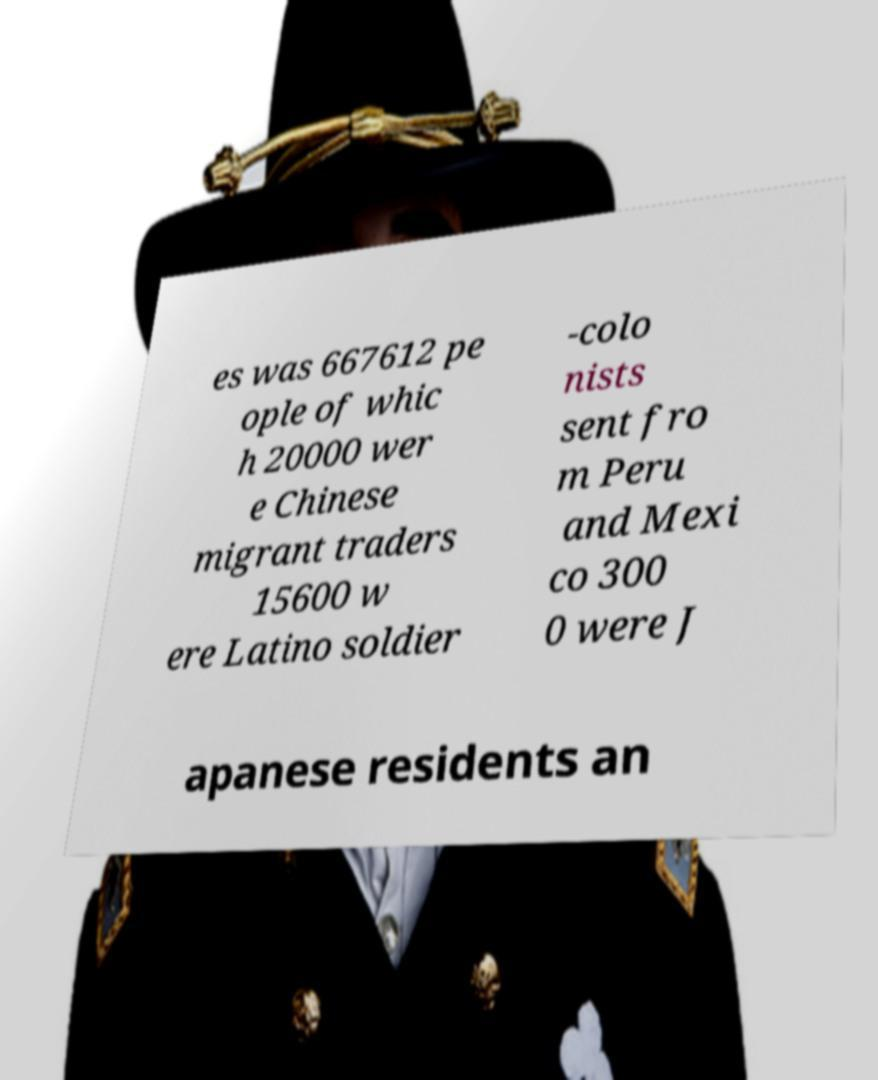Please identify and transcribe the text found in this image. es was 667612 pe ople of whic h 20000 wer e Chinese migrant traders 15600 w ere Latino soldier -colo nists sent fro m Peru and Mexi co 300 0 were J apanese residents an 